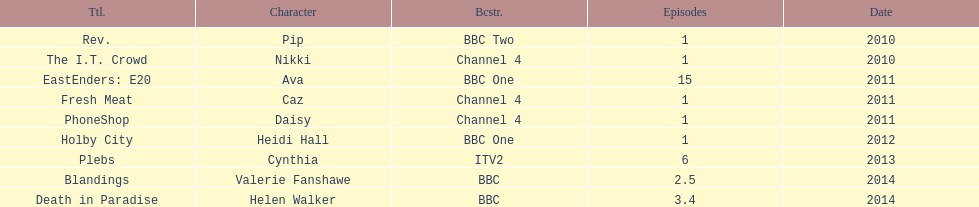What is the only role she played with broadcaster itv2? Cynthia. 